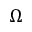Convert formula to latex. <formula><loc_0><loc_0><loc_500><loc_500>\Omega</formula> 